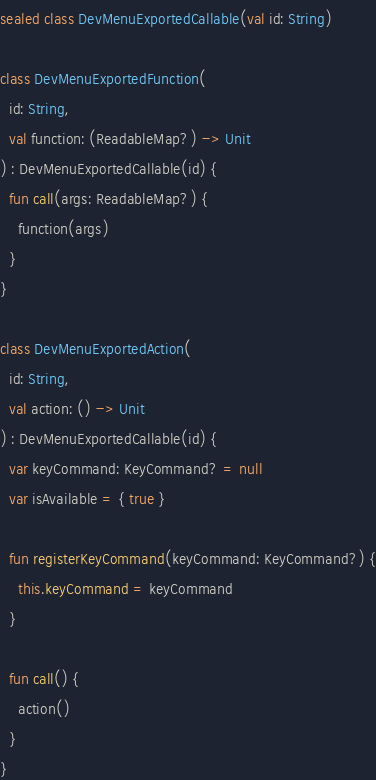<code> <loc_0><loc_0><loc_500><loc_500><_Kotlin_>sealed class DevMenuExportedCallable(val id: String)

class DevMenuExportedFunction(
  id: String,
  val function: (ReadableMap?) -> Unit
) : DevMenuExportedCallable(id) {
  fun call(args: ReadableMap?) {
    function(args)
  }
}

class DevMenuExportedAction(
  id: String,
  val action: () -> Unit
) : DevMenuExportedCallable(id) {
  var keyCommand: KeyCommand? = null
  var isAvailable = { true }

  fun registerKeyCommand(keyCommand: KeyCommand?) {
    this.keyCommand = keyCommand
  }

  fun call() {
    action()
  }
}
</code> 